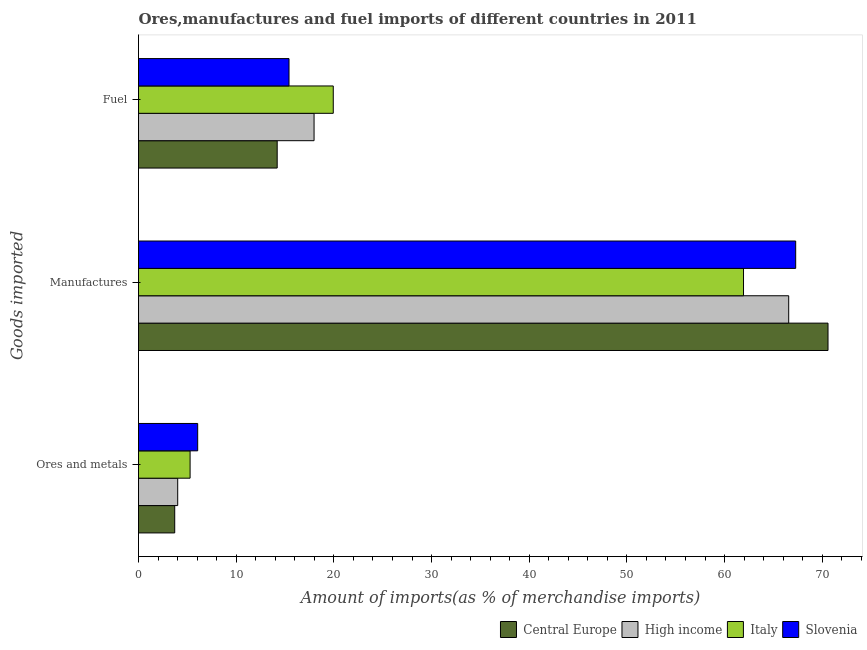How many different coloured bars are there?
Offer a terse response. 4. How many groups of bars are there?
Give a very brief answer. 3. Are the number of bars per tick equal to the number of legend labels?
Make the answer very short. Yes. What is the label of the 1st group of bars from the top?
Give a very brief answer. Fuel. What is the percentage of ores and metals imports in Central Europe?
Your answer should be compact. 3.71. Across all countries, what is the maximum percentage of fuel imports?
Offer a very short reply. 19.94. Across all countries, what is the minimum percentage of ores and metals imports?
Your answer should be very brief. 3.71. In which country was the percentage of ores and metals imports maximum?
Your answer should be compact. Slovenia. In which country was the percentage of manufactures imports minimum?
Your response must be concise. Italy. What is the total percentage of ores and metals imports in the graph?
Your response must be concise. 19.06. What is the difference between the percentage of fuel imports in High income and that in Slovenia?
Your answer should be very brief. 2.56. What is the difference between the percentage of ores and metals imports in Central Europe and the percentage of fuel imports in Italy?
Your response must be concise. -16.23. What is the average percentage of manufactures imports per country?
Make the answer very short. 66.59. What is the difference between the percentage of ores and metals imports and percentage of manufactures imports in High income?
Offer a very short reply. -62.55. What is the ratio of the percentage of ores and metals imports in High income to that in Italy?
Your answer should be very brief. 0.76. What is the difference between the highest and the second highest percentage of manufactures imports?
Make the answer very short. 3.31. What is the difference between the highest and the lowest percentage of manufactures imports?
Your response must be concise. 8.65. What does the 3rd bar from the bottom in Ores and metals represents?
Your answer should be very brief. Italy. How many bars are there?
Your answer should be compact. 12. How many countries are there in the graph?
Provide a succinct answer. 4. Are the values on the major ticks of X-axis written in scientific E-notation?
Give a very brief answer. No. How are the legend labels stacked?
Provide a succinct answer. Horizontal. What is the title of the graph?
Make the answer very short. Ores,manufactures and fuel imports of different countries in 2011. What is the label or title of the X-axis?
Ensure brevity in your answer.  Amount of imports(as % of merchandise imports). What is the label or title of the Y-axis?
Keep it short and to the point. Goods imported. What is the Amount of imports(as % of merchandise imports) of Central Europe in Ores and metals?
Your answer should be very brief. 3.71. What is the Amount of imports(as % of merchandise imports) of High income in Ores and metals?
Your response must be concise. 4.01. What is the Amount of imports(as % of merchandise imports) in Italy in Ores and metals?
Provide a short and direct response. 5.28. What is the Amount of imports(as % of merchandise imports) in Slovenia in Ores and metals?
Ensure brevity in your answer.  6.06. What is the Amount of imports(as % of merchandise imports) of Central Europe in Manufactures?
Your answer should be very brief. 70.59. What is the Amount of imports(as % of merchandise imports) of High income in Manufactures?
Make the answer very short. 66.56. What is the Amount of imports(as % of merchandise imports) of Italy in Manufactures?
Keep it short and to the point. 61.94. What is the Amount of imports(as % of merchandise imports) of Slovenia in Manufactures?
Your response must be concise. 67.28. What is the Amount of imports(as % of merchandise imports) of Central Europe in Fuel?
Give a very brief answer. 14.2. What is the Amount of imports(as % of merchandise imports) of High income in Fuel?
Provide a short and direct response. 17.97. What is the Amount of imports(as % of merchandise imports) in Italy in Fuel?
Provide a short and direct response. 19.94. What is the Amount of imports(as % of merchandise imports) of Slovenia in Fuel?
Provide a succinct answer. 15.41. Across all Goods imported, what is the maximum Amount of imports(as % of merchandise imports) of Central Europe?
Give a very brief answer. 70.59. Across all Goods imported, what is the maximum Amount of imports(as % of merchandise imports) in High income?
Offer a terse response. 66.56. Across all Goods imported, what is the maximum Amount of imports(as % of merchandise imports) of Italy?
Provide a succinct answer. 61.94. Across all Goods imported, what is the maximum Amount of imports(as % of merchandise imports) in Slovenia?
Provide a short and direct response. 67.28. Across all Goods imported, what is the minimum Amount of imports(as % of merchandise imports) of Central Europe?
Make the answer very short. 3.71. Across all Goods imported, what is the minimum Amount of imports(as % of merchandise imports) of High income?
Make the answer very short. 4.01. Across all Goods imported, what is the minimum Amount of imports(as % of merchandise imports) of Italy?
Keep it short and to the point. 5.28. Across all Goods imported, what is the minimum Amount of imports(as % of merchandise imports) in Slovenia?
Ensure brevity in your answer.  6.06. What is the total Amount of imports(as % of merchandise imports) of Central Europe in the graph?
Give a very brief answer. 88.49. What is the total Amount of imports(as % of merchandise imports) of High income in the graph?
Offer a very short reply. 88.55. What is the total Amount of imports(as % of merchandise imports) of Italy in the graph?
Give a very brief answer. 87.16. What is the total Amount of imports(as % of merchandise imports) of Slovenia in the graph?
Provide a short and direct response. 88.75. What is the difference between the Amount of imports(as % of merchandise imports) of Central Europe in Ores and metals and that in Manufactures?
Provide a short and direct response. -66.88. What is the difference between the Amount of imports(as % of merchandise imports) in High income in Ores and metals and that in Manufactures?
Your answer should be very brief. -62.55. What is the difference between the Amount of imports(as % of merchandise imports) of Italy in Ores and metals and that in Manufactures?
Keep it short and to the point. -56.66. What is the difference between the Amount of imports(as % of merchandise imports) in Slovenia in Ores and metals and that in Manufactures?
Ensure brevity in your answer.  -61.22. What is the difference between the Amount of imports(as % of merchandise imports) of Central Europe in Ores and metals and that in Fuel?
Give a very brief answer. -10.49. What is the difference between the Amount of imports(as % of merchandise imports) in High income in Ores and metals and that in Fuel?
Provide a succinct answer. -13.96. What is the difference between the Amount of imports(as % of merchandise imports) of Italy in Ores and metals and that in Fuel?
Provide a succinct answer. -14.66. What is the difference between the Amount of imports(as % of merchandise imports) in Slovenia in Ores and metals and that in Fuel?
Your answer should be compact. -9.35. What is the difference between the Amount of imports(as % of merchandise imports) of Central Europe in Manufactures and that in Fuel?
Provide a short and direct response. 56.39. What is the difference between the Amount of imports(as % of merchandise imports) in High income in Manufactures and that in Fuel?
Provide a succinct answer. 48.59. What is the difference between the Amount of imports(as % of merchandise imports) of Italy in Manufactures and that in Fuel?
Your answer should be compact. 42. What is the difference between the Amount of imports(as % of merchandise imports) in Slovenia in Manufactures and that in Fuel?
Offer a terse response. 51.87. What is the difference between the Amount of imports(as % of merchandise imports) of Central Europe in Ores and metals and the Amount of imports(as % of merchandise imports) of High income in Manufactures?
Your answer should be compact. -62.86. What is the difference between the Amount of imports(as % of merchandise imports) of Central Europe in Ores and metals and the Amount of imports(as % of merchandise imports) of Italy in Manufactures?
Offer a very short reply. -58.23. What is the difference between the Amount of imports(as % of merchandise imports) of Central Europe in Ores and metals and the Amount of imports(as % of merchandise imports) of Slovenia in Manufactures?
Ensure brevity in your answer.  -63.57. What is the difference between the Amount of imports(as % of merchandise imports) of High income in Ores and metals and the Amount of imports(as % of merchandise imports) of Italy in Manufactures?
Provide a short and direct response. -57.93. What is the difference between the Amount of imports(as % of merchandise imports) of High income in Ores and metals and the Amount of imports(as % of merchandise imports) of Slovenia in Manufactures?
Your response must be concise. -63.27. What is the difference between the Amount of imports(as % of merchandise imports) in Italy in Ores and metals and the Amount of imports(as % of merchandise imports) in Slovenia in Manufactures?
Your answer should be very brief. -62. What is the difference between the Amount of imports(as % of merchandise imports) of Central Europe in Ores and metals and the Amount of imports(as % of merchandise imports) of High income in Fuel?
Ensure brevity in your answer.  -14.26. What is the difference between the Amount of imports(as % of merchandise imports) in Central Europe in Ores and metals and the Amount of imports(as % of merchandise imports) in Italy in Fuel?
Keep it short and to the point. -16.23. What is the difference between the Amount of imports(as % of merchandise imports) in Central Europe in Ores and metals and the Amount of imports(as % of merchandise imports) in Slovenia in Fuel?
Provide a short and direct response. -11.7. What is the difference between the Amount of imports(as % of merchandise imports) of High income in Ores and metals and the Amount of imports(as % of merchandise imports) of Italy in Fuel?
Provide a succinct answer. -15.93. What is the difference between the Amount of imports(as % of merchandise imports) in High income in Ores and metals and the Amount of imports(as % of merchandise imports) in Slovenia in Fuel?
Your response must be concise. -11.4. What is the difference between the Amount of imports(as % of merchandise imports) in Italy in Ores and metals and the Amount of imports(as % of merchandise imports) in Slovenia in Fuel?
Offer a very short reply. -10.13. What is the difference between the Amount of imports(as % of merchandise imports) of Central Europe in Manufactures and the Amount of imports(as % of merchandise imports) of High income in Fuel?
Offer a very short reply. 52.62. What is the difference between the Amount of imports(as % of merchandise imports) in Central Europe in Manufactures and the Amount of imports(as % of merchandise imports) in Italy in Fuel?
Your answer should be compact. 50.65. What is the difference between the Amount of imports(as % of merchandise imports) in Central Europe in Manufactures and the Amount of imports(as % of merchandise imports) in Slovenia in Fuel?
Keep it short and to the point. 55.18. What is the difference between the Amount of imports(as % of merchandise imports) in High income in Manufactures and the Amount of imports(as % of merchandise imports) in Italy in Fuel?
Your answer should be very brief. 46.63. What is the difference between the Amount of imports(as % of merchandise imports) of High income in Manufactures and the Amount of imports(as % of merchandise imports) of Slovenia in Fuel?
Keep it short and to the point. 51.15. What is the difference between the Amount of imports(as % of merchandise imports) in Italy in Manufactures and the Amount of imports(as % of merchandise imports) in Slovenia in Fuel?
Provide a succinct answer. 46.53. What is the average Amount of imports(as % of merchandise imports) in Central Europe per Goods imported?
Ensure brevity in your answer.  29.5. What is the average Amount of imports(as % of merchandise imports) of High income per Goods imported?
Make the answer very short. 29.52. What is the average Amount of imports(as % of merchandise imports) in Italy per Goods imported?
Provide a succinct answer. 29.05. What is the average Amount of imports(as % of merchandise imports) of Slovenia per Goods imported?
Your answer should be compact. 29.58. What is the difference between the Amount of imports(as % of merchandise imports) of Central Europe and Amount of imports(as % of merchandise imports) of High income in Ores and metals?
Your response must be concise. -0.3. What is the difference between the Amount of imports(as % of merchandise imports) of Central Europe and Amount of imports(as % of merchandise imports) of Italy in Ores and metals?
Give a very brief answer. -1.57. What is the difference between the Amount of imports(as % of merchandise imports) of Central Europe and Amount of imports(as % of merchandise imports) of Slovenia in Ores and metals?
Your response must be concise. -2.35. What is the difference between the Amount of imports(as % of merchandise imports) of High income and Amount of imports(as % of merchandise imports) of Italy in Ores and metals?
Ensure brevity in your answer.  -1.27. What is the difference between the Amount of imports(as % of merchandise imports) of High income and Amount of imports(as % of merchandise imports) of Slovenia in Ores and metals?
Provide a short and direct response. -2.05. What is the difference between the Amount of imports(as % of merchandise imports) in Italy and Amount of imports(as % of merchandise imports) in Slovenia in Ores and metals?
Keep it short and to the point. -0.78. What is the difference between the Amount of imports(as % of merchandise imports) of Central Europe and Amount of imports(as % of merchandise imports) of High income in Manufactures?
Give a very brief answer. 4.02. What is the difference between the Amount of imports(as % of merchandise imports) in Central Europe and Amount of imports(as % of merchandise imports) in Italy in Manufactures?
Offer a terse response. 8.65. What is the difference between the Amount of imports(as % of merchandise imports) of Central Europe and Amount of imports(as % of merchandise imports) of Slovenia in Manufactures?
Provide a succinct answer. 3.31. What is the difference between the Amount of imports(as % of merchandise imports) in High income and Amount of imports(as % of merchandise imports) in Italy in Manufactures?
Offer a terse response. 4.63. What is the difference between the Amount of imports(as % of merchandise imports) in High income and Amount of imports(as % of merchandise imports) in Slovenia in Manufactures?
Offer a very short reply. -0.71. What is the difference between the Amount of imports(as % of merchandise imports) of Italy and Amount of imports(as % of merchandise imports) of Slovenia in Manufactures?
Ensure brevity in your answer.  -5.34. What is the difference between the Amount of imports(as % of merchandise imports) of Central Europe and Amount of imports(as % of merchandise imports) of High income in Fuel?
Your answer should be compact. -3.77. What is the difference between the Amount of imports(as % of merchandise imports) in Central Europe and Amount of imports(as % of merchandise imports) in Italy in Fuel?
Keep it short and to the point. -5.74. What is the difference between the Amount of imports(as % of merchandise imports) of Central Europe and Amount of imports(as % of merchandise imports) of Slovenia in Fuel?
Provide a succinct answer. -1.21. What is the difference between the Amount of imports(as % of merchandise imports) of High income and Amount of imports(as % of merchandise imports) of Italy in Fuel?
Your answer should be very brief. -1.97. What is the difference between the Amount of imports(as % of merchandise imports) in High income and Amount of imports(as % of merchandise imports) in Slovenia in Fuel?
Your answer should be compact. 2.56. What is the difference between the Amount of imports(as % of merchandise imports) of Italy and Amount of imports(as % of merchandise imports) of Slovenia in Fuel?
Your response must be concise. 4.53. What is the ratio of the Amount of imports(as % of merchandise imports) in Central Europe in Ores and metals to that in Manufactures?
Provide a short and direct response. 0.05. What is the ratio of the Amount of imports(as % of merchandise imports) in High income in Ores and metals to that in Manufactures?
Your answer should be very brief. 0.06. What is the ratio of the Amount of imports(as % of merchandise imports) in Italy in Ores and metals to that in Manufactures?
Give a very brief answer. 0.09. What is the ratio of the Amount of imports(as % of merchandise imports) in Slovenia in Ores and metals to that in Manufactures?
Provide a short and direct response. 0.09. What is the ratio of the Amount of imports(as % of merchandise imports) of Central Europe in Ores and metals to that in Fuel?
Keep it short and to the point. 0.26. What is the ratio of the Amount of imports(as % of merchandise imports) in High income in Ores and metals to that in Fuel?
Offer a terse response. 0.22. What is the ratio of the Amount of imports(as % of merchandise imports) of Italy in Ores and metals to that in Fuel?
Your answer should be compact. 0.26. What is the ratio of the Amount of imports(as % of merchandise imports) in Slovenia in Ores and metals to that in Fuel?
Your answer should be compact. 0.39. What is the ratio of the Amount of imports(as % of merchandise imports) in Central Europe in Manufactures to that in Fuel?
Provide a succinct answer. 4.97. What is the ratio of the Amount of imports(as % of merchandise imports) in High income in Manufactures to that in Fuel?
Give a very brief answer. 3.7. What is the ratio of the Amount of imports(as % of merchandise imports) in Italy in Manufactures to that in Fuel?
Give a very brief answer. 3.11. What is the ratio of the Amount of imports(as % of merchandise imports) in Slovenia in Manufactures to that in Fuel?
Offer a very short reply. 4.37. What is the difference between the highest and the second highest Amount of imports(as % of merchandise imports) of Central Europe?
Give a very brief answer. 56.39. What is the difference between the highest and the second highest Amount of imports(as % of merchandise imports) of High income?
Give a very brief answer. 48.59. What is the difference between the highest and the second highest Amount of imports(as % of merchandise imports) in Italy?
Offer a terse response. 42. What is the difference between the highest and the second highest Amount of imports(as % of merchandise imports) of Slovenia?
Provide a succinct answer. 51.87. What is the difference between the highest and the lowest Amount of imports(as % of merchandise imports) of Central Europe?
Offer a very short reply. 66.88. What is the difference between the highest and the lowest Amount of imports(as % of merchandise imports) in High income?
Keep it short and to the point. 62.55. What is the difference between the highest and the lowest Amount of imports(as % of merchandise imports) in Italy?
Your response must be concise. 56.66. What is the difference between the highest and the lowest Amount of imports(as % of merchandise imports) of Slovenia?
Offer a terse response. 61.22. 